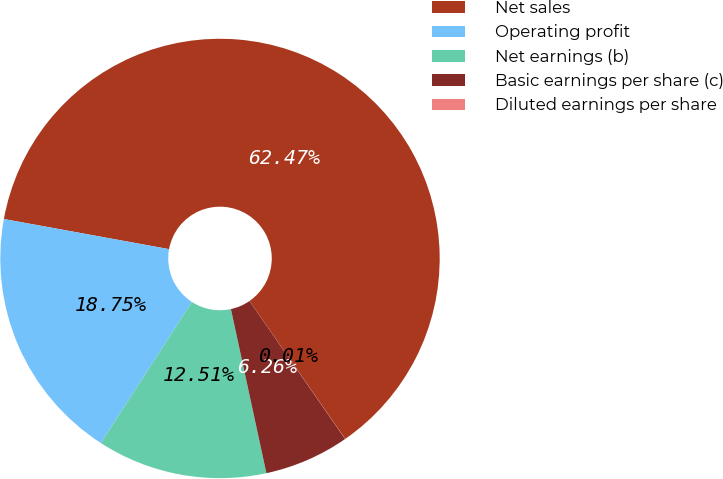Convert chart to OTSL. <chart><loc_0><loc_0><loc_500><loc_500><pie_chart><fcel>Net sales<fcel>Operating profit<fcel>Net earnings (b)<fcel>Basic earnings per share (c)<fcel>Diluted earnings per share<nl><fcel>62.47%<fcel>18.75%<fcel>12.51%<fcel>6.26%<fcel>0.01%<nl></chart> 